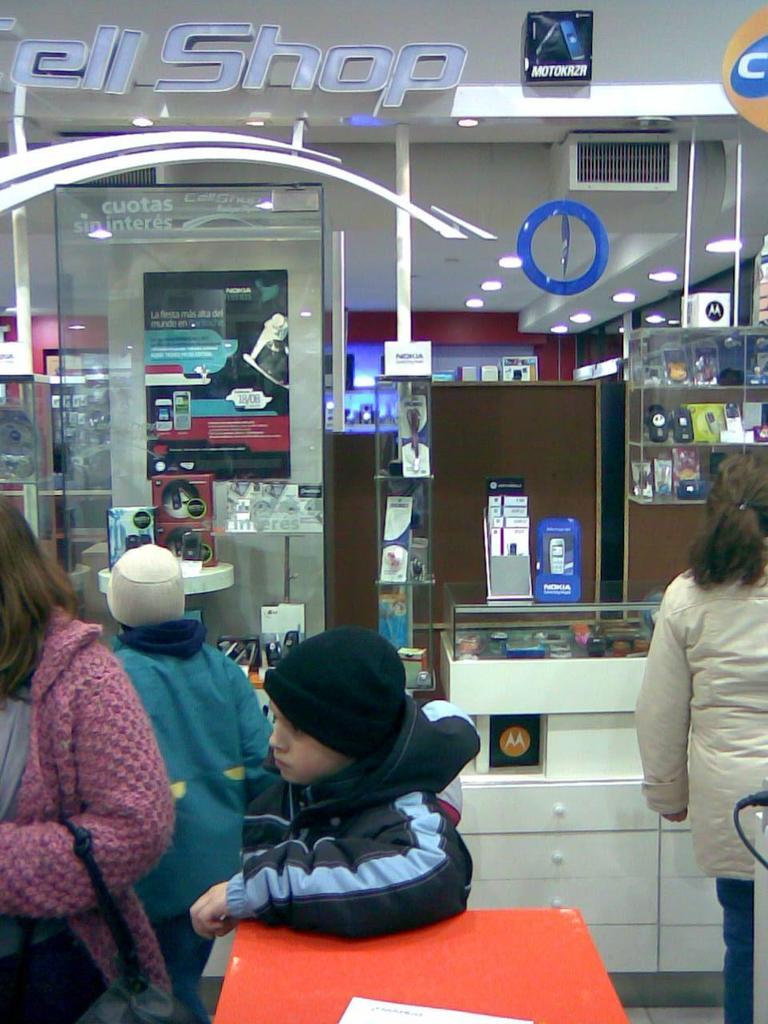Is this a shop?
Provide a short and direct response. Yes. 